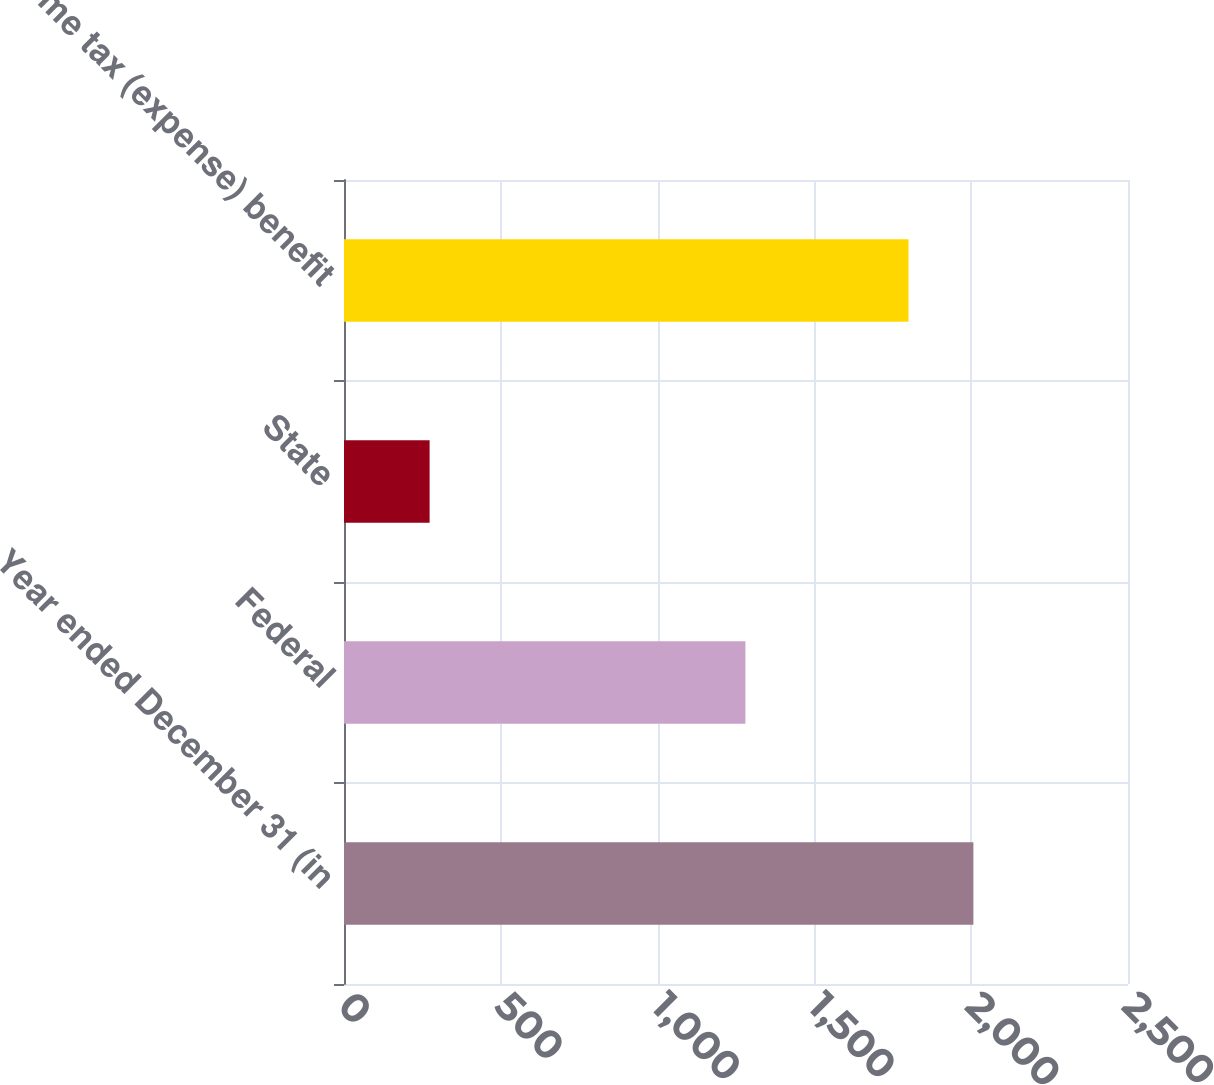Convert chart. <chart><loc_0><loc_0><loc_500><loc_500><bar_chart><fcel>Year ended December 31 (in<fcel>Federal<fcel>State<fcel>Income tax (expense) benefit<nl><fcel>2007<fcel>1280<fcel>273<fcel>1800<nl></chart> 